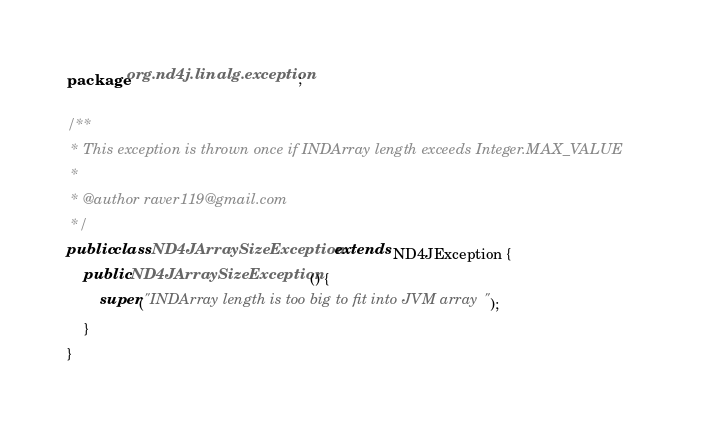<code> <loc_0><loc_0><loc_500><loc_500><_Java_>package org.nd4j.linalg.exception;

/**
 * This exception is thrown once if INDArray length exceeds Integer.MAX_VALUE
 *
 * @author raver119@gmail.com
 */
public class ND4JArraySizeException extends ND4JException {
    public ND4JArraySizeException() {
        super("INDArray length is too big to fit into JVM array");
    }
}
</code> 